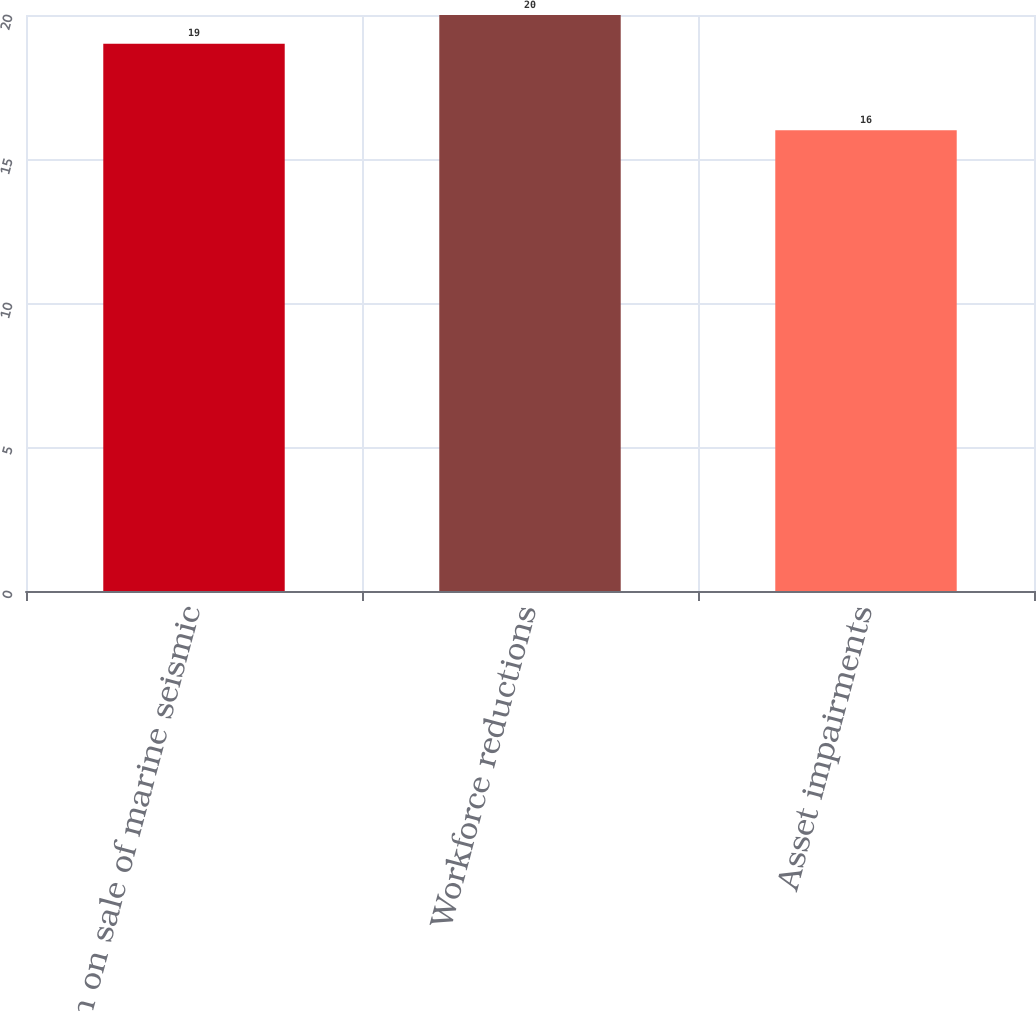Convert chart. <chart><loc_0><loc_0><loc_500><loc_500><bar_chart><fcel>Gain on sale of marine seismic<fcel>Workforce reductions<fcel>Asset impairments<nl><fcel>19<fcel>20<fcel>16<nl></chart> 